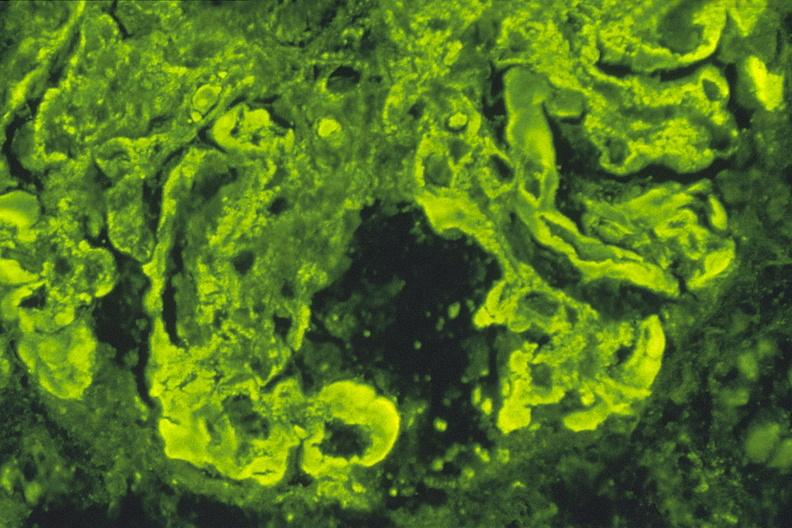does atrophy secondary to pituitectomy show sle iv kappa, 40x?
Answer the question using a single word or phrase. No 